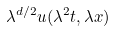<formula> <loc_0><loc_0><loc_500><loc_500>\lambda ^ { d / 2 } u ( \lambda ^ { 2 } t , \lambda x )</formula> 